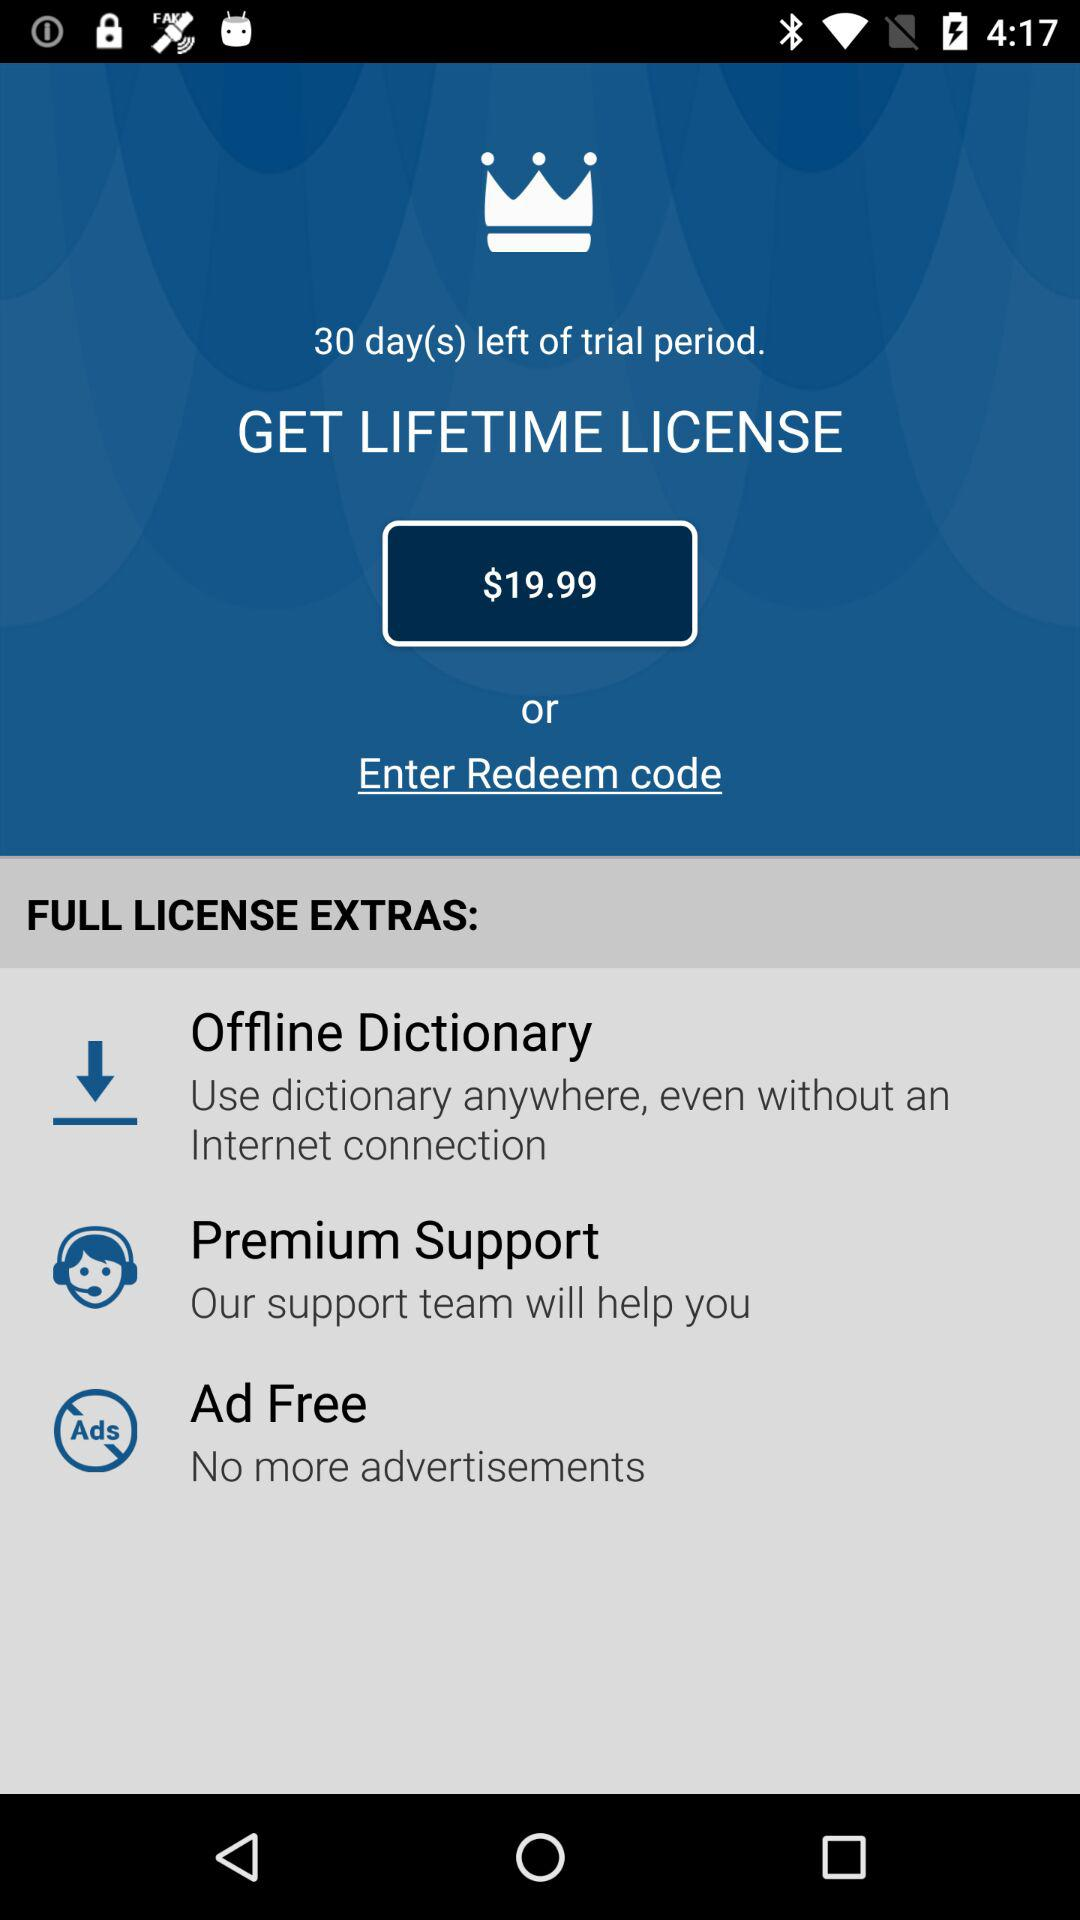How many features are included in the full license?
Answer the question using a single word or phrase. 3 